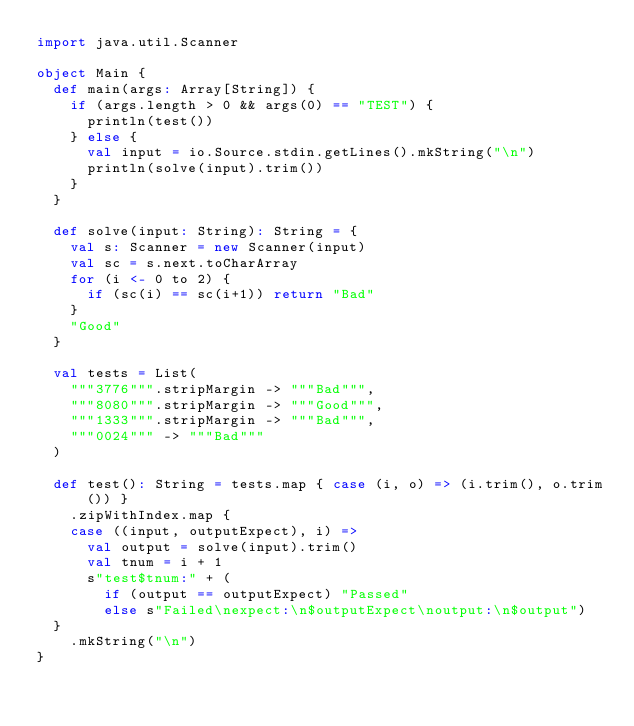Convert code to text. <code><loc_0><loc_0><loc_500><loc_500><_Scala_>import java.util.Scanner

object Main {
  def main(args: Array[String]) {
    if (args.length > 0 && args(0) == "TEST") {
      println(test())
    } else {
      val input = io.Source.stdin.getLines().mkString("\n")
      println(solve(input).trim())
    }
  }

  def solve(input: String): String = {
    val s: Scanner = new Scanner(input)
    val sc = s.next.toCharArray
    for (i <- 0 to 2) {
      if (sc(i) == sc(i+1)) return "Bad"
    }
    "Good"
  }

  val tests = List(
    """3776""".stripMargin -> """Bad""",
    """8080""".stripMargin -> """Good""",
    """1333""".stripMargin -> """Bad""",
    """0024""" -> """Bad"""
  )

  def test(): String = tests.map { case (i, o) => (i.trim(), o.trim()) }
    .zipWithIndex.map {
    case ((input, outputExpect), i) =>
      val output = solve(input).trim()
      val tnum = i + 1
      s"test$tnum:" + (
        if (output == outputExpect) "Passed"
        else s"Failed\nexpect:\n$outputExpect\noutput:\n$output")
  }
    .mkString("\n")
}</code> 